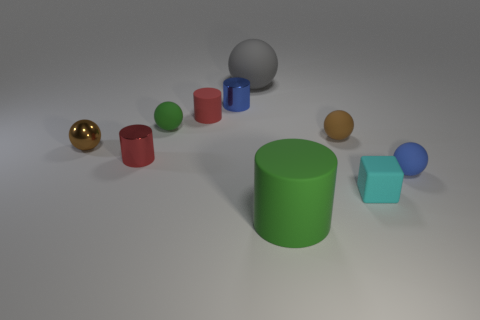Is the shape of the green matte thing in front of the tiny blue rubber thing the same as the green object that is behind the blue ball?
Your answer should be compact. No. There is a sphere that is both left of the cyan block and to the right of the green rubber cylinder; what size is it?
Give a very brief answer. Small. What number of other objects are there of the same color as the large matte sphere?
Provide a succinct answer. 0. Is the material of the small red cylinder that is in front of the small green object the same as the tiny green thing?
Offer a very short reply. No. Is there any other thing that has the same size as the red matte object?
Ensure brevity in your answer.  Yes. Are there fewer small matte cylinders right of the tiny green ball than brown things in front of the tiny blue matte ball?
Your answer should be very brief. No. Is there any other thing that is the same shape as the big green rubber object?
Your answer should be very brief. Yes. What is the material of the object that is the same color as the shiny ball?
Offer a very short reply. Rubber. There is a green object left of the green cylinder that is to the right of the red shiny object; how many balls are on the left side of it?
Your answer should be compact. 1. How many big objects are in front of the large gray matte object?
Offer a terse response. 1. 